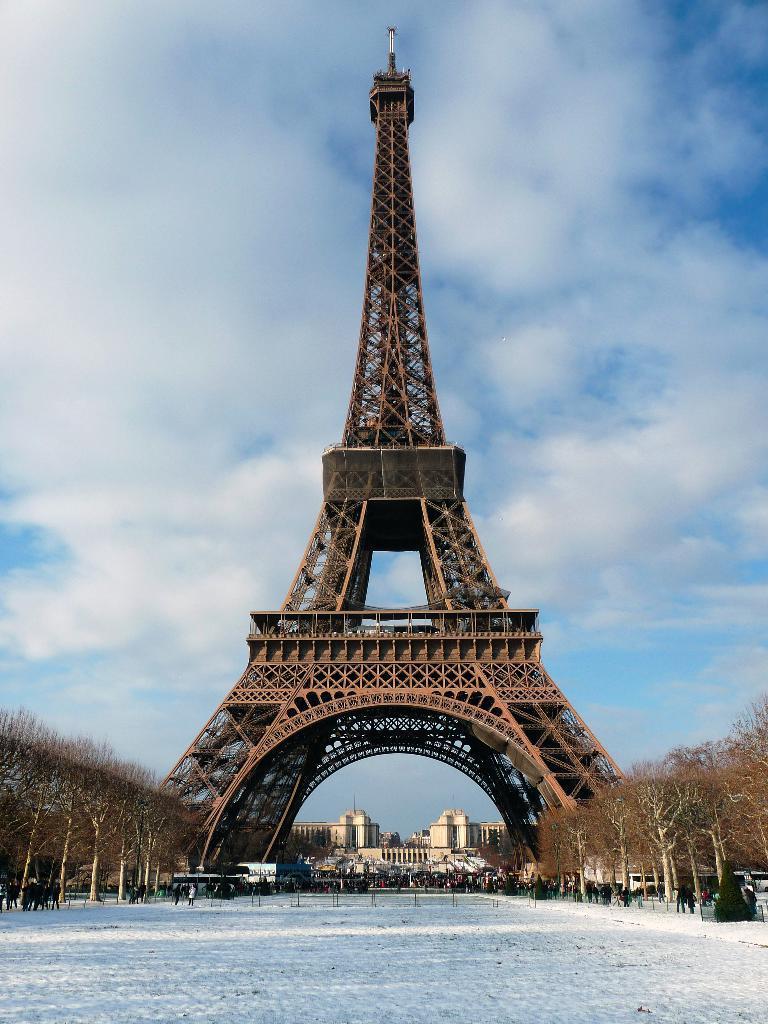In one or two sentences, can you explain what this image depicts? There is an Eiffel tower. Here we can see trees, vehicles, buildings, and group of people. In the background we can see sky with clouds. 